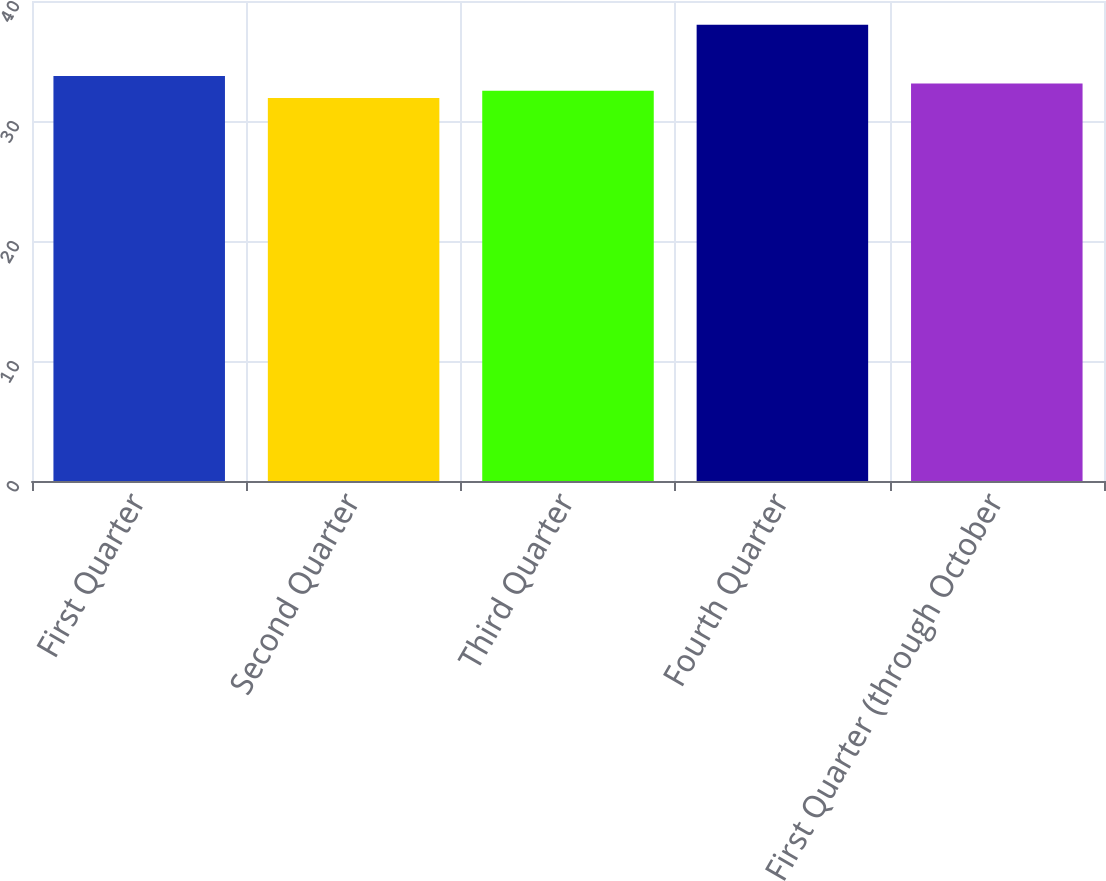<chart> <loc_0><loc_0><loc_500><loc_500><bar_chart><fcel>First Quarter<fcel>Second Quarter<fcel>Third Quarter<fcel>Fourth Quarter<fcel>First Quarter (through October<nl><fcel>33.74<fcel>31.91<fcel>32.52<fcel>38.02<fcel>33.13<nl></chart> 